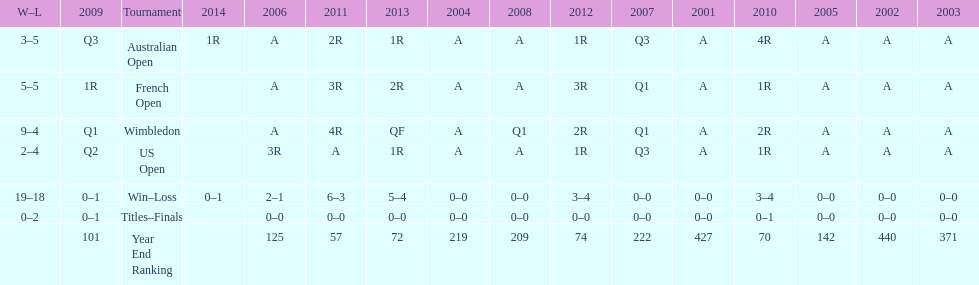I'm looking to parse the entire table for insights. Could you assist me with that? {'header': ['W–L', '2009', 'Tournament', '2014', '2006', '2011', '2013', '2004', '2008', '2012', '2007', '2001', '2010', '2005', '2002', '2003'], 'rows': [['3–5', 'Q3', 'Australian Open', '1R', 'A', '2R', '1R', 'A', 'A', '1R', 'Q3', 'A', '4R', 'A', 'A', 'A'], ['5–5', '1R', 'French Open', '', 'A', '3R', '2R', 'A', 'A', '3R', 'Q1', 'A', '1R', 'A', 'A', 'A'], ['9–4', 'Q1', 'Wimbledon', '', 'A', '4R', 'QF', 'A', 'Q1', '2R', 'Q1', 'A', '2R', 'A', 'A', 'A'], ['2–4', 'Q2', 'US Open', '', '3R', 'A', '1R', 'A', 'A', '1R', 'Q3', 'A', '1R', 'A', 'A', 'A'], ['19–18', '0–1', 'Win–Loss', '0–1', '2–1', '6–3', '5–4', '0–0', '0–0', '3–4', '0–0', '0–0', '3–4', '0–0', '0–0', '0–0'], ['0–2', '0–1', 'Titles–Finals', '', '0–0', '0–0', '0–0', '0–0', '0–0', '0–0', '0–0', '0–0', '0–1', '0–0', '0–0', '0–0'], ['', '101', 'Year End Ranking', '', '125', '57', '72', '219', '209', '74', '222', '427', '70', '142', '440', '371']]} Which tournament has the largest total win record? Wimbledon. 